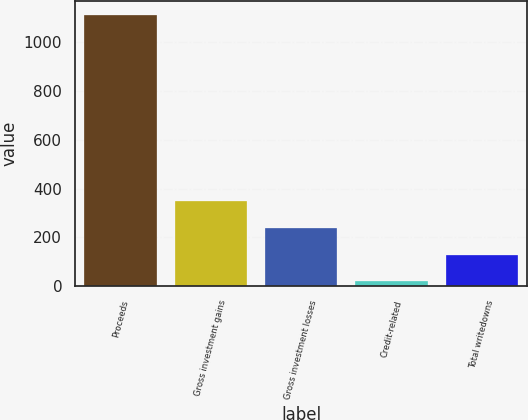<chart> <loc_0><loc_0><loc_500><loc_500><bar_chart><fcel>Proceeds<fcel>Gross investment gains<fcel>Gross investment losses<fcel>Credit-related<fcel>Total writedowns<nl><fcel>1112<fcel>346.9<fcel>237.6<fcel>19<fcel>128.3<nl></chart> 